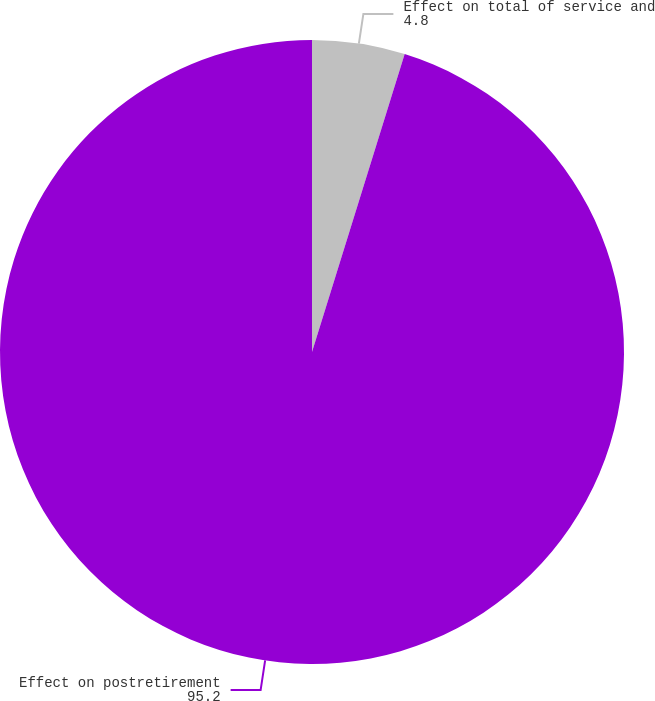<chart> <loc_0><loc_0><loc_500><loc_500><pie_chart><fcel>Effect on total of service and<fcel>Effect on postretirement<nl><fcel>4.8%<fcel>95.2%<nl></chart> 